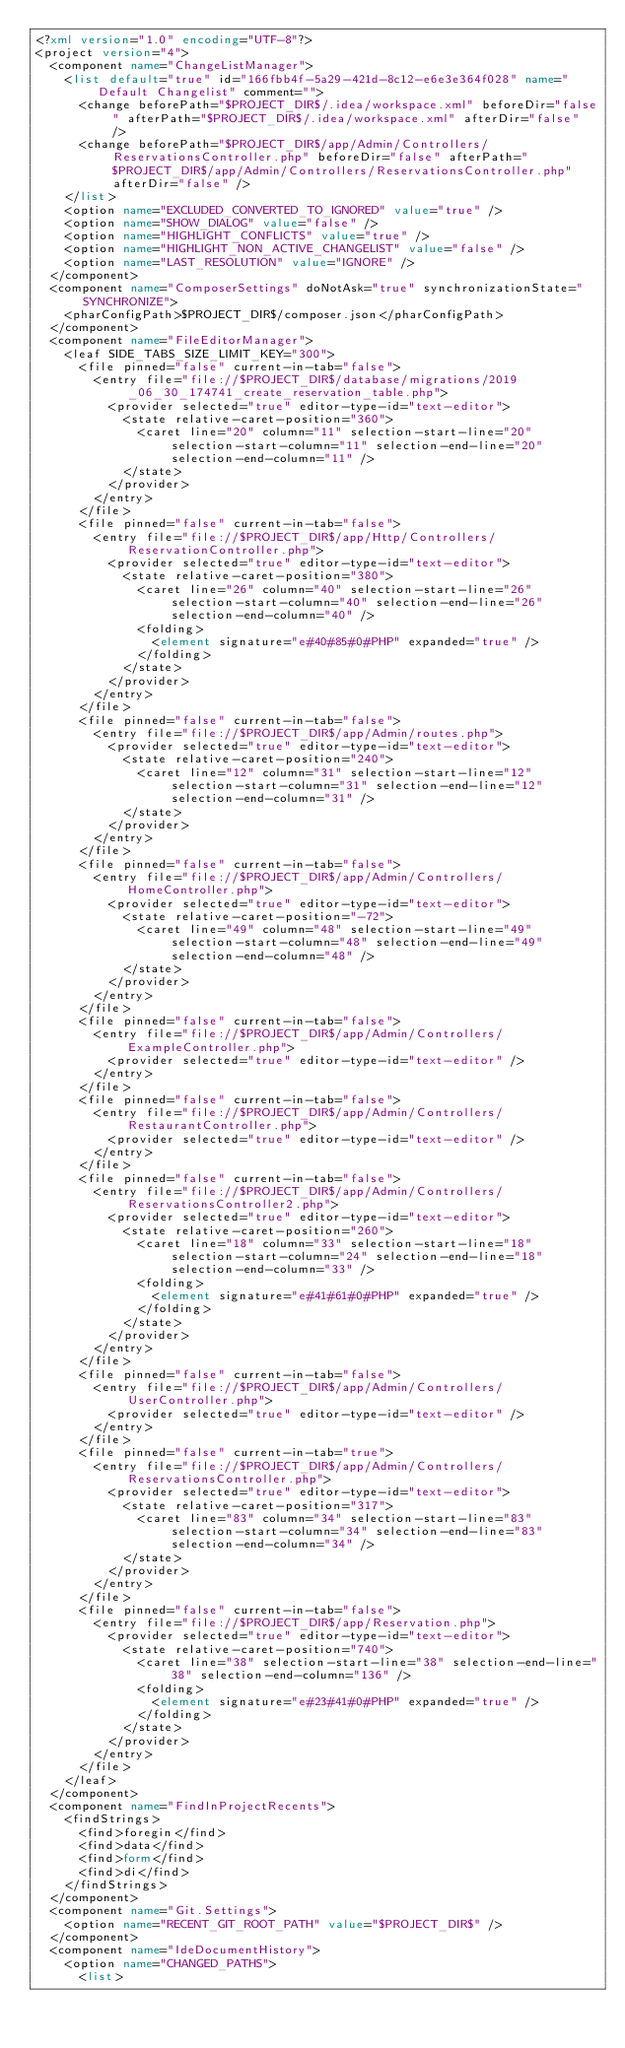<code> <loc_0><loc_0><loc_500><loc_500><_XML_><?xml version="1.0" encoding="UTF-8"?>
<project version="4">
  <component name="ChangeListManager">
    <list default="true" id="166fbb4f-5a29-421d-8c12-e6e3e364f028" name="Default Changelist" comment="">
      <change beforePath="$PROJECT_DIR$/.idea/workspace.xml" beforeDir="false" afterPath="$PROJECT_DIR$/.idea/workspace.xml" afterDir="false" />
      <change beforePath="$PROJECT_DIR$/app/Admin/Controllers/ReservationsController.php" beforeDir="false" afterPath="$PROJECT_DIR$/app/Admin/Controllers/ReservationsController.php" afterDir="false" />
    </list>
    <option name="EXCLUDED_CONVERTED_TO_IGNORED" value="true" />
    <option name="SHOW_DIALOG" value="false" />
    <option name="HIGHLIGHT_CONFLICTS" value="true" />
    <option name="HIGHLIGHT_NON_ACTIVE_CHANGELIST" value="false" />
    <option name="LAST_RESOLUTION" value="IGNORE" />
  </component>
  <component name="ComposerSettings" doNotAsk="true" synchronizationState="SYNCHRONIZE">
    <pharConfigPath>$PROJECT_DIR$/composer.json</pharConfigPath>
  </component>
  <component name="FileEditorManager">
    <leaf SIDE_TABS_SIZE_LIMIT_KEY="300">
      <file pinned="false" current-in-tab="false">
        <entry file="file://$PROJECT_DIR$/database/migrations/2019_06_30_174741_create_reservation_table.php">
          <provider selected="true" editor-type-id="text-editor">
            <state relative-caret-position="360">
              <caret line="20" column="11" selection-start-line="20" selection-start-column="11" selection-end-line="20" selection-end-column="11" />
            </state>
          </provider>
        </entry>
      </file>
      <file pinned="false" current-in-tab="false">
        <entry file="file://$PROJECT_DIR$/app/Http/Controllers/ReservationController.php">
          <provider selected="true" editor-type-id="text-editor">
            <state relative-caret-position="380">
              <caret line="26" column="40" selection-start-line="26" selection-start-column="40" selection-end-line="26" selection-end-column="40" />
              <folding>
                <element signature="e#40#85#0#PHP" expanded="true" />
              </folding>
            </state>
          </provider>
        </entry>
      </file>
      <file pinned="false" current-in-tab="false">
        <entry file="file://$PROJECT_DIR$/app/Admin/routes.php">
          <provider selected="true" editor-type-id="text-editor">
            <state relative-caret-position="240">
              <caret line="12" column="31" selection-start-line="12" selection-start-column="31" selection-end-line="12" selection-end-column="31" />
            </state>
          </provider>
        </entry>
      </file>
      <file pinned="false" current-in-tab="false">
        <entry file="file://$PROJECT_DIR$/app/Admin/Controllers/HomeController.php">
          <provider selected="true" editor-type-id="text-editor">
            <state relative-caret-position="-72">
              <caret line="49" column="48" selection-start-line="49" selection-start-column="48" selection-end-line="49" selection-end-column="48" />
            </state>
          </provider>
        </entry>
      </file>
      <file pinned="false" current-in-tab="false">
        <entry file="file://$PROJECT_DIR$/app/Admin/Controllers/ExampleController.php">
          <provider selected="true" editor-type-id="text-editor" />
        </entry>
      </file>
      <file pinned="false" current-in-tab="false">
        <entry file="file://$PROJECT_DIR$/app/Admin/Controllers/RestaurantController.php">
          <provider selected="true" editor-type-id="text-editor" />
        </entry>
      </file>
      <file pinned="false" current-in-tab="false">
        <entry file="file://$PROJECT_DIR$/app/Admin/Controllers/ReservationsController2.php">
          <provider selected="true" editor-type-id="text-editor">
            <state relative-caret-position="260">
              <caret line="18" column="33" selection-start-line="18" selection-start-column="24" selection-end-line="18" selection-end-column="33" />
              <folding>
                <element signature="e#41#61#0#PHP" expanded="true" />
              </folding>
            </state>
          </provider>
        </entry>
      </file>
      <file pinned="false" current-in-tab="false">
        <entry file="file://$PROJECT_DIR$/app/Admin/Controllers/UserController.php">
          <provider selected="true" editor-type-id="text-editor" />
        </entry>
      </file>
      <file pinned="false" current-in-tab="true">
        <entry file="file://$PROJECT_DIR$/app/Admin/Controllers/ReservationsController.php">
          <provider selected="true" editor-type-id="text-editor">
            <state relative-caret-position="317">
              <caret line="83" column="34" selection-start-line="83" selection-start-column="34" selection-end-line="83" selection-end-column="34" />
            </state>
          </provider>
        </entry>
      </file>
      <file pinned="false" current-in-tab="false">
        <entry file="file://$PROJECT_DIR$/app/Reservation.php">
          <provider selected="true" editor-type-id="text-editor">
            <state relative-caret-position="740">
              <caret line="38" selection-start-line="38" selection-end-line="38" selection-end-column="136" />
              <folding>
                <element signature="e#23#41#0#PHP" expanded="true" />
              </folding>
            </state>
          </provider>
        </entry>
      </file>
    </leaf>
  </component>
  <component name="FindInProjectRecents">
    <findStrings>
      <find>foregin</find>
      <find>data</find>
      <find>form</find>
      <find>di</find>
    </findStrings>
  </component>
  <component name="Git.Settings">
    <option name="RECENT_GIT_ROOT_PATH" value="$PROJECT_DIR$" />
  </component>
  <component name="IdeDocumentHistory">
    <option name="CHANGED_PATHS">
      <list></code> 